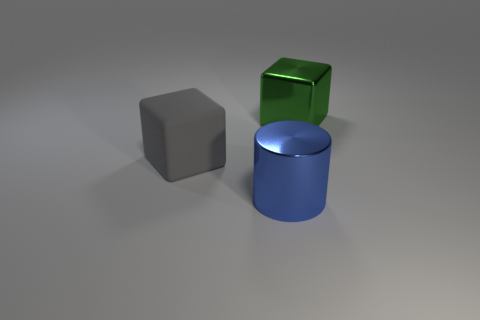There is a matte thing that is the same size as the metallic block; what is its shape? cube 